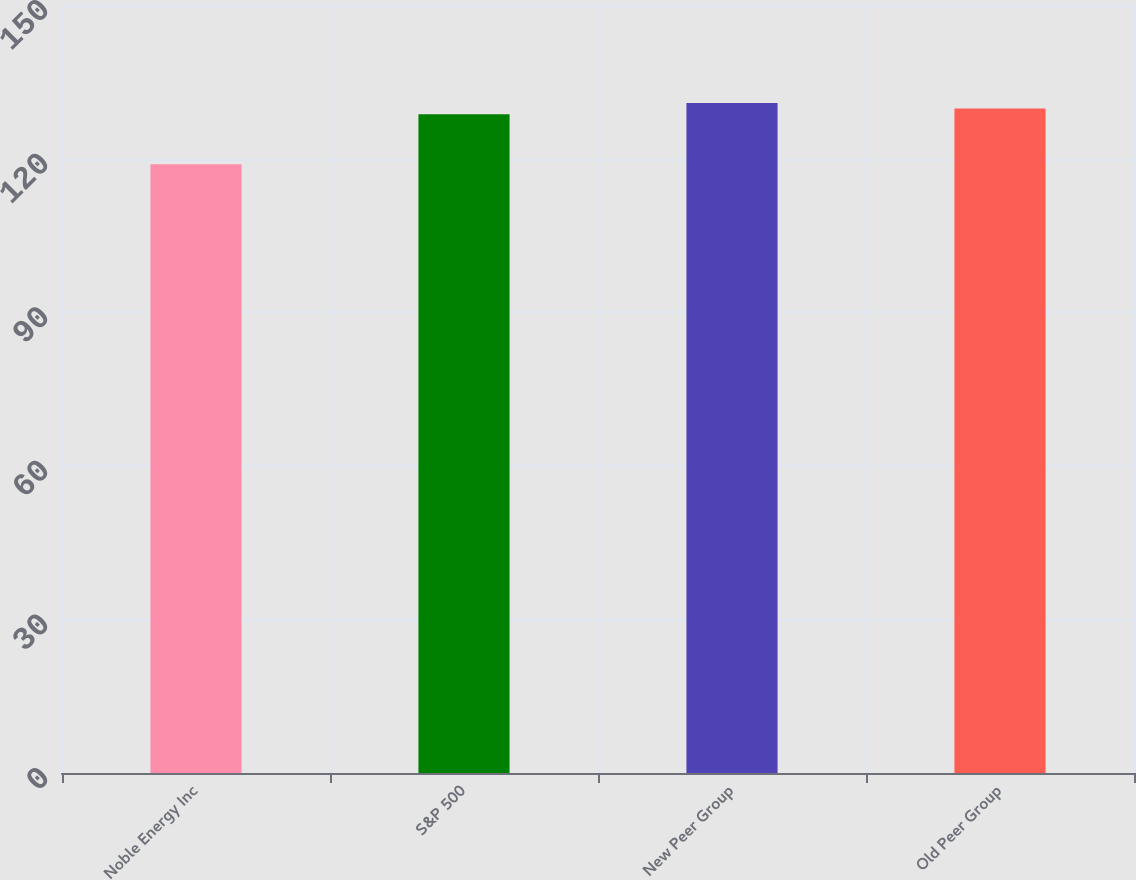Convert chart to OTSL. <chart><loc_0><loc_0><loc_500><loc_500><bar_chart><fcel>Noble Energy Inc<fcel>S&P 500<fcel>New Peer Group<fcel>Old Peer Group<nl><fcel>118.88<fcel>128.68<fcel>130.86<fcel>129.77<nl></chart> 